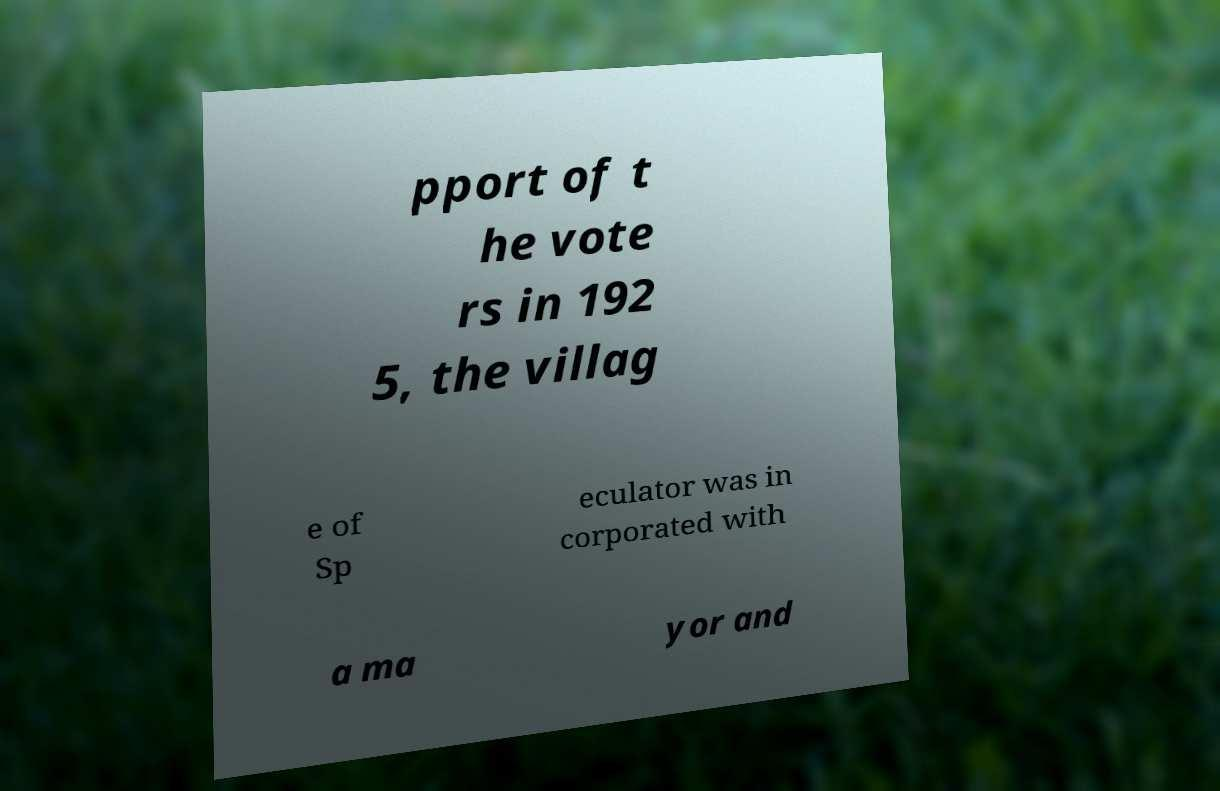For documentation purposes, I need the text within this image transcribed. Could you provide that? pport of t he vote rs in 192 5, the villag e of Sp eculator was in corporated with a ma yor and 